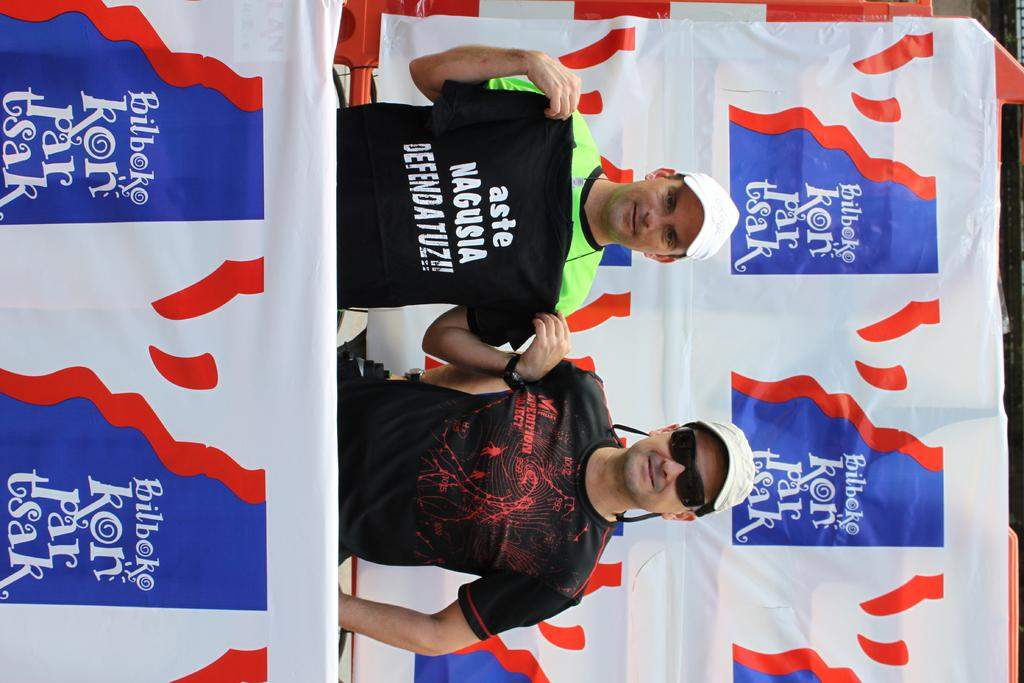What can be seen in the image? There are men standing in the image. Where are the men standing? The men are standing on the floor. What can be seen in the background of the image? There are advertisements in the background of the image. What type of popcorn is being sold in the image? There is no popcorn present in the image. What color is the powder on the men's hands in the image? There is no powder or indication of any substance on the men's hands in the image. 